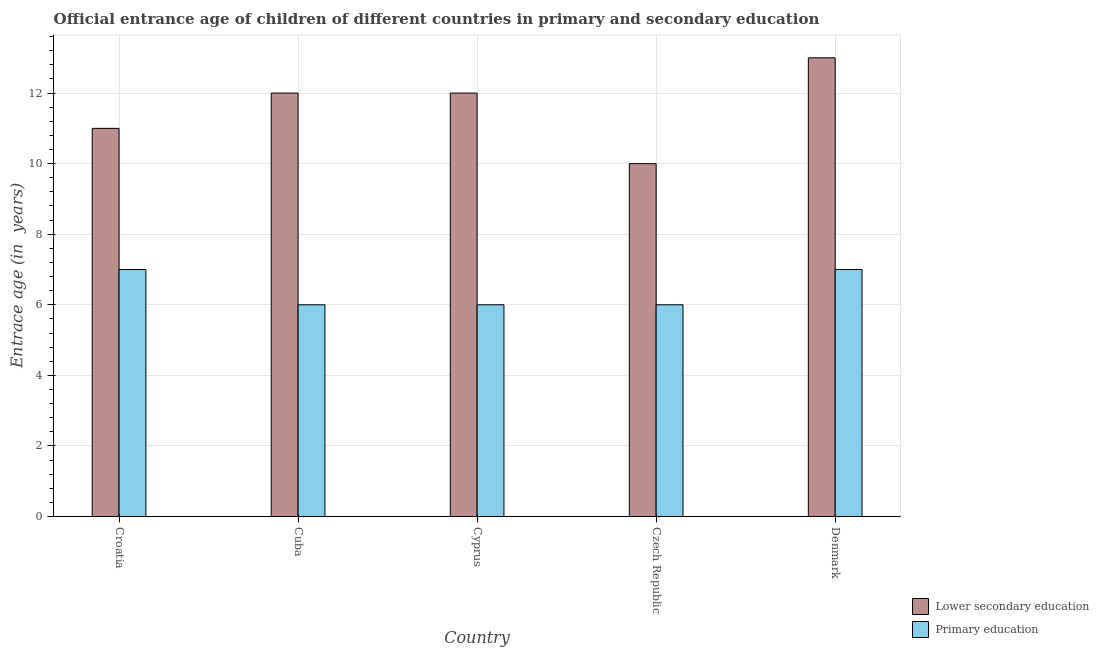How many groups of bars are there?
Ensure brevity in your answer.  5. How many bars are there on the 5th tick from the left?
Your answer should be compact. 2. What is the label of the 2nd group of bars from the left?
Provide a short and direct response. Cuba. In how many cases, is the number of bars for a given country not equal to the number of legend labels?
Make the answer very short. 0. What is the entrance age of children in lower secondary education in Cuba?
Your response must be concise. 12. Across all countries, what is the maximum entrance age of children in lower secondary education?
Make the answer very short. 13. In which country was the entrance age of chiildren in primary education maximum?
Ensure brevity in your answer.  Croatia. In which country was the entrance age of children in lower secondary education minimum?
Your response must be concise. Czech Republic. What is the total entrance age of chiildren in primary education in the graph?
Provide a succinct answer. 32. What is the difference between the entrance age of chiildren in primary education in Croatia and that in Denmark?
Keep it short and to the point. 0. What is the difference between the entrance age of chiildren in primary education in Denmark and the entrance age of children in lower secondary education in Czech Republic?
Provide a short and direct response. -3. What is the difference between the entrance age of children in lower secondary education and entrance age of chiildren in primary education in Cyprus?
Your answer should be compact. 6. What is the ratio of the entrance age of chiildren in primary education in Czech Republic to that in Denmark?
Your response must be concise. 0.86. Is the entrance age of children in lower secondary education in Cuba less than that in Cyprus?
Offer a very short reply. No. Is the difference between the entrance age of chiildren in primary education in Cyprus and Czech Republic greater than the difference between the entrance age of children in lower secondary education in Cyprus and Czech Republic?
Ensure brevity in your answer.  No. What is the difference between the highest and the second highest entrance age of chiildren in primary education?
Keep it short and to the point. 0. What is the difference between the highest and the lowest entrance age of children in lower secondary education?
Give a very brief answer. 3. Is the sum of the entrance age of chiildren in primary education in Cuba and Denmark greater than the maximum entrance age of children in lower secondary education across all countries?
Offer a terse response. No. What does the 1st bar from the left in Denmark represents?
Provide a short and direct response. Lower secondary education. What does the 1st bar from the right in Czech Republic represents?
Keep it short and to the point. Primary education. How many bars are there?
Keep it short and to the point. 10. How many countries are there in the graph?
Offer a terse response. 5. What is the difference between two consecutive major ticks on the Y-axis?
Offer a terse response. 2. Are the values on the major ticks of Y-axis written in scientific E-notation?
Offer a very short reply. No. Does the graph contain grids?
Provide a succinct answer. Yes. How many legend labels are there?
Ensure brevity in your answer.  2. What is the title of the graph?
Give a very brief answer. Official entrance age of children of different countries in primary and secondary education. Does "RDB concessional" appear as one of the legend labels in the graph?
Offer a terse response. No. What is the label or title of the Y-axis?
Make the answer very short. Entrace age (in  years). What is the Entrace age (in  years) of Lower secondary education in Croatia?
Your answer should be compact. 11. What is the Entrace age (in  years) of Primary education in Cuba?
Your answer should be very brief. 6. What is the Entrace age (in  years) of Primary education in Cyprus?
Your response must be concise. 6. What is the Entrace age (in  years) in Primary education in Czech Republic?
Keep it short and to the point. 6. What is the Entrace age (in  years) in Primary education in Denmark?
Your response must be concise. 7. Across all countries, what is the minimum Entrace age (in  years) in Lower secondary education?
Your response must be concise. 10. What is the total Entrace age (in  years) in Lower secondary education in the graph?
Your answer should be compact. 58. What is the difference between the Entrace age (in  years) in Lower secondary education in Croatia and that in Cuba?
Give a very brief answer. -1. What is the difference between the Entrace age (in  years) of Primary education in Croatia and that in Cuba?
Your response must be concise. 1. What is the difference between the Entrace age (in  years) in Lower secondary education in Croatia and that in Czech Republic?
Keep it short and to the point. 1. What is the difference between the Entrace age (in  years) in Primary education in Croatia and that in Czech Republic?
Your answer should be compact. 1. What is the difference between the Entrace age (in  years) in Primary education in Croatia and that in Denmark?
Offer a very short reply. 0. What is the difference between the Entrace age (in  years) of Primary education in Cuba and that in Cyprus?
Make the answer very short. 0. What is the difference between the Entrace age (in  years) in Lower secondary education in Cuba and that in Czech Republic?
Make the answer very short. 2. What is the difference between the Entrace age (in  years) of Primary education in Cuba and that in Czech Republic?
Keep it short and to the point. 0. What is the difference between the Entrace age (in  years) in Lower secondary education in Croatia and the Entrace age (in  years) in Primary education in Cyprus?
Provide a short and direct response. 5. What is the difference between the Entrace age (in  years) in Lower secondary education in Cuba and the Entrace age (in  years) in Primary education in Cyprus?
Your answer should be very brief. 6. What is the difference between the Entrace age (in  years) of Lower secondary education in Cyprus and the Entrace age (in  years) of Primary education in Czech Republic?
Offer a very short reply. 6. What is the difference between the Entrace age (in  years) in Lower secondary education in Cyprus and the Entrace age (in  years) in Primary education in Denmark?
Ensure brevity in your answer.  5. What is the difference between the Entrace age (in  years) in Lower secondary education in Czech Republic and the Entrace age (in  years) in Primary education in Denmark?
Offer a terse response. 3. What is the average Entrace age (in  years) of Lower secondary education per country?
Ensure brevity in your answer.  11.6. What is the difference between the Entrace age (in  years) in Lower secondary education and Entrace age (in  years) in Primary education in Cuba?
Provide a succinct answer. 6. What is the difference between the Entrace age (in  years) of Lower secondary education and Entrace age (in  years) of Primary education in Cyprus?
Give a very brief answer. 6. What is the difference between the Entrace age (in  years) in Lower secondary education and Entrace age (in  years) in Primary education in Denmark?
Make the answer very short. 6. What is the ratio of the Entrace age (in  years) of Primary education in Croatia to that in Cyprus?
Offer a terse response. 1.17. What is the ratio of the Entrace age (in  years) of Lower secondary education in Croatia to that in Czech Republic?
Keep it short and to the point. 1.1. What is the ratio of the Entrace age (in  years) in Primary education in Croatia to that in Czech Republic?
Make the answer very short. 1.17. What is the ratio of the Entrace age (in  years) in Lower secondary education in Croatia to that in Denmark?
Offer a very short reply. 0.85. What is the ratio of the Entrace age (in  years) of Primary education in Croatia to that in Denmark?
Provide a succinct answer. 1. What is the ratio of the Entrace age (in  years) in Lower secondary education in Cuba to that in Czech Republic?
Your answer should be very brief. 1.2. What is the ratio of the Entrace age (in  years) in Primary education in Cuba to that in Czech Republic?
Offer a terse response. 1. What is the ratio of the Entrace age (in  years) of Lower secondary education in Cuba to that in Denmark?
Your response must be concise. 0.92. What is the ratio of the Entrace age (in  years) in Lower secondary education in Cyprus to that in Denmark?
Your answer should be very brief. 0.92. What is the ratio of the Entrace age (in  years) in Primary education in Cyprus to that in Denmark?
Ensure brevity in your answer.  0.86. What is the ratio of the Entrace age (in  years) of Lower secondary education in Czech Republic to that in Denmark?
Your answer should be very brief. 0.77. What is the difference between the highest and the second highest Entrace age (in  years) of Primary education?
Your answer should be compact. 0. What is the difference between the highest and the lowest Entrace age (in  years) of Lower secondary education?
Give a very brief answer. 3. What is the difference between the highest and the lowest Entrace age (in  years) of Primary education?
Ensure brevity in your answer.  1. 